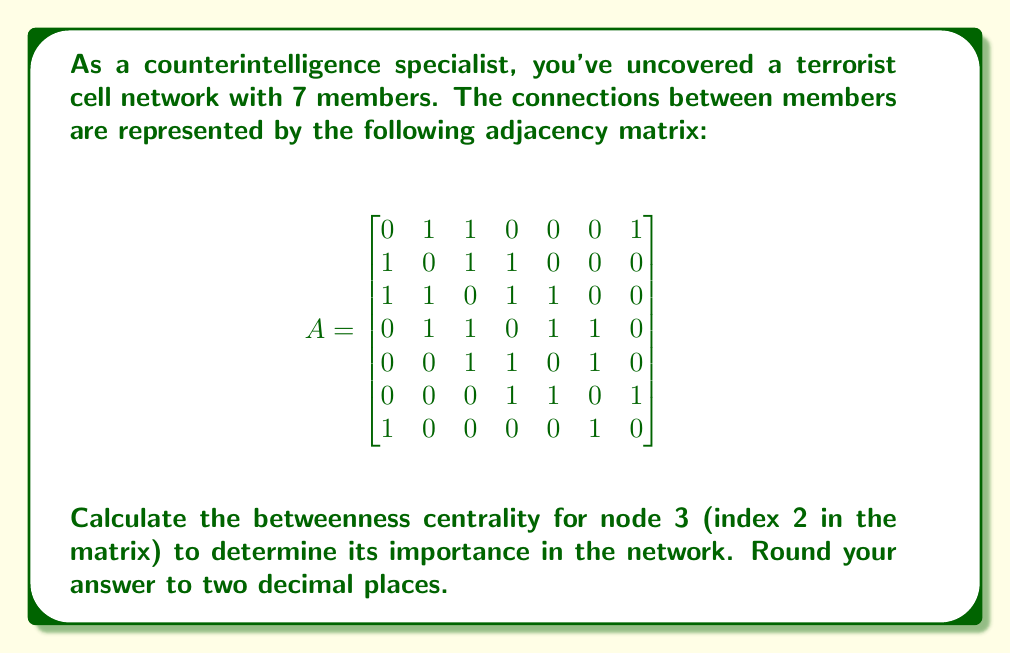Teach me how to tackle this problem. To calculate the betweenness centrality for node 3, we need to follow these steps:

1) First, we need to find all shortest paths between every pair of nodes in the network.

2) Then, we count how many of these shortest paths pass through node 3.

3) The betweenness centrality is calculated using the formula:

   $$C_B(v) = \sum_{s \neq v \neq t} \frac{\sigma_{st}(v)}{\sigma_{st}}$$

   where $\sigma_{st}$ is the total number of shortest paths from node s to node t, and $\sigma_{st}(v)$ is the number of those paths that pass through v.

4) Let's count the shortest paths through node 3:
   - Between 1 and 4: 1 out of 1
   - Between 1 and 5: 1 out of 1
   - Between 2 and 5: 1 out of 1
   - Between 1 and 6: 1 out of 2
   - Between 2 and 6: 1 out of 1
   - Between 7 and 2: 1 out of 2
   - Between 7 and 4: 1 out of 2
   - Between 7 and 5: 1 out of 2

5) Sum up the fractions:

   $$C_B(3) = 1 + 1 + 1 + \frac{1}{2} + 1 + \frac{1}{2} + \frac{1}{2} + \frac{1}{2} = 6$$

6) Normalize by dividing by $(n-1)(n-2)/2 = (7-1)(7-2)/2 = 15$, where n is the number of nodes:

   $$C_B'(3) = \frac{6}{15} = 0.4$$

Therefore, the normalized betweenness centrality for node 3 is 0.40.
Answer: 0.40 